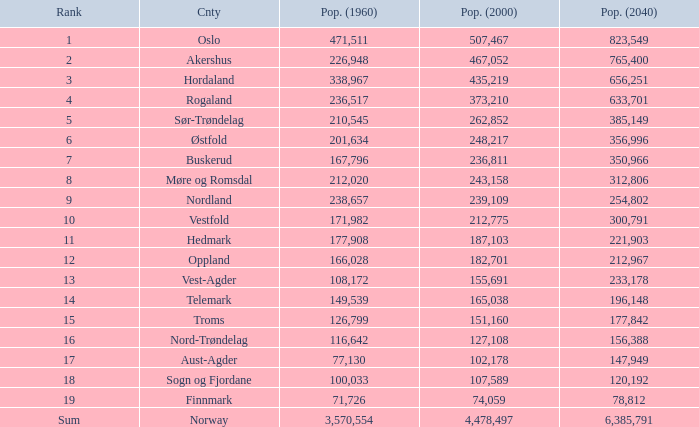What was the population of a county in 2040 that had a population less than 108,172 in 2000 and less than 107,589 in 1960? 2.0. Help me parse the entirety of this table. {'header': ['Rank', 'Cnty', 'Pop. (1960)', 'Pop. (2000)', 'Pop. (2040)'], 'rows': [['1', 'Oslo', '471,511', '507,467', '823,549'], ['2', 'Akershus', '226,948', '467,052', '765,400'], ['3', 'Hordaland', '338,967', '435,219', '656,251'], ['4', 'Rogaland', '236,517', '373,210', '633,701'], ['5', 'Sør-Trøndelag', '210,545', '262,852', '385,149'], ['6', 'Østfold', '201,634', '248,217', '356,996'], ['7', 'Buskerud', '167,796', '236,811', '350,966'], ['8', 'Møre og Romsdal', '212,020', '243,158', '312,806'], ['9', 'Nordland', '238,657', '239,109', '254,802'], ['10', 'Vestfold', '171,982', '212,775', '300,791'], ['11', 'Hedmark', '177,908', '187,103', '221,903'], ['12', 'Oppland', '166,028', '182,701', '212,967'], ['13', 'Vest-Agder', '108,172', '155,691', '233,178'], ['14', 'Telemark', '149,539', '165,038', '196,148'], ['15', 'Troms', '126,799', '151,160', '177,842'], ['16', 'Nord-Trøndelag', '116,642', '127,108', '156,388'], ['17', 'Aust-Agder', '77,130', '102,178', '147,949'], ['18', 'Sogn og Fjordane', '100,033', '107,589', '120,192'], ['19', 'Finnmark', '71,726', '74,059', '78,812'], ['Sum', 'Norway', '3,570,554', '4,478,497', '6,385,791']]} 